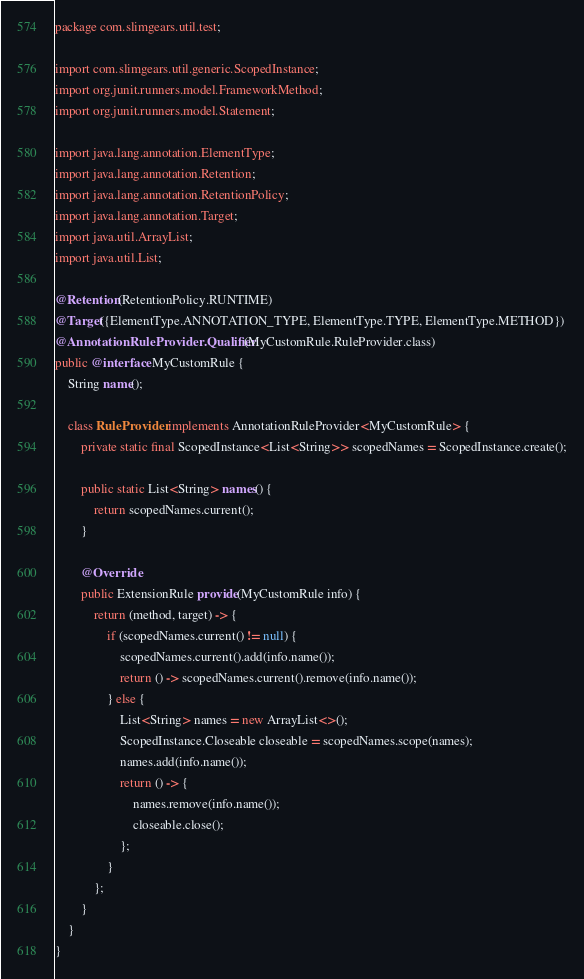Convert code to text. <code><loc_0><loc_0><loc_500><loc_500><_Java_>package com.slimgears.util.test;

import com.slimgears.util.generic.ScopedInstance;
import org.junit.runners.model.FrameworkMethod;
import org.junit.runners.model.Statement;

import java.lang.annotation.ElementType;
import java.lang.annotation.Retention;
import java.lang.annotation.RetentionPolicy;
import java.lang.annotation.Target;
import java.util.ArrayList;
import java.util.List;

@Retention(RetentionPolicy.RUNTIME)
@Target({ElementType.ANNOTATION_TYPE, ElementType.TYPE, ElementType.METHOD})
@AnnotationRuleProvider.Qualifier(MyCustomRule.RuleProvider.class)
public @interface MyCustomRule {
    String name();

    class RuleProvider implements AnnotationRuleProvider<MyCustomRule> {
        private static final ScopedInstance<List<String>> scopedNames = ScopedInstance.create();

        public static List<String> names() {
            return scopedNames.current();
        }

        @Override
        public ExtensionRule provide(MyCustomRule info) {
            return (method, target) -> {
                if (scopedNames.current() != null) {
                    scopedNames.current().add(info.name());
                    return () -> scopedNames.current().remove(info.name());
                } else {
                    List<String> names = new ArrayList<>();
                    ScopedInstance.Closeable closeable = scopedNames.scope(names);
                    names.add(info.name());
                    return () -> {
                        names.remove(info.name());
                        closeable.close();
                    };
                }
            };
        }
    }
}
</code> 